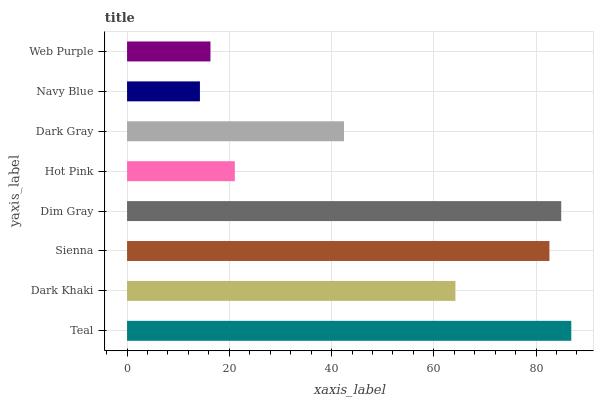Is Navy Blue the minimum?
Answer yes or no. Yes. Is Teal the maximum?
Answer yes or no. Yes. Is Dark Khaki the minimum?
Answer yes or no. No. Is Dark Khaki the maximum?
Answer yes or no. No. Is Teal greater than Dark Khaki?
Answer yes or no. Yes. Is Dark Khaki less than Teal?
Answer yes or no. Yes. Is Dark Khaki greater than Teal?
Answer yes or no. No. Is Teal less than Dark Khaki?
Answer yes or no. No. Is Dark Khaki the high median?
Answer yes or no. Yes. Is Dark Gray the low median?
Answer yes or no. Yes. Is Web Purple the high median?
Answer yes or no. No. Is Teal the low median?
Answer yes or no. No. 